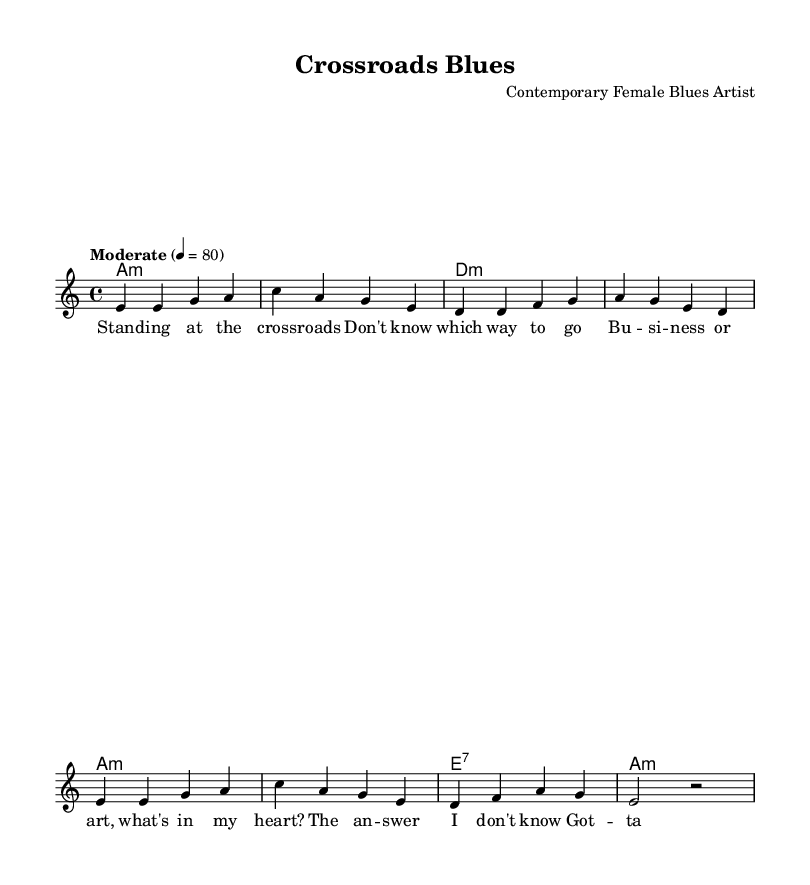What is the key signature of this music? The key signature is indicated by the key of A minor, which has no sharps or flats.
Answer: A minor What is the time signature of this piece? The time signature is located at the beginning of the score, and it shows that there are four beats in a measure.
Answer: 4/4 What is the tempo marking for this song? The tempo marking specifies "Moderate" at a speed of four beats per minute, which gives an indication of how fast the piece should be played.
Answer: Moderate, 80 How many measures are in the melody? Counting each line of the melody indicates that there are eight measures total, as there are four measures in each of the two lines.
Answer: 8 What is the highest note in the melody? By examining the notes in the melody section, the highest note is "a," which appears in multiple places throughout the piece.
Answer: a What kind of chord is played at the beginning of the song? The first chord is labeled as "A minor," which sets the tonality for the piece. The chord names indicate the quality of the chord.
Answer: A minor What themes are presented in the lyrics? The lyrics discuss feelings of uncertainty regarding career choices, prominently featuring the theme of crossroads in life and decisions.
Answer: Career choices 